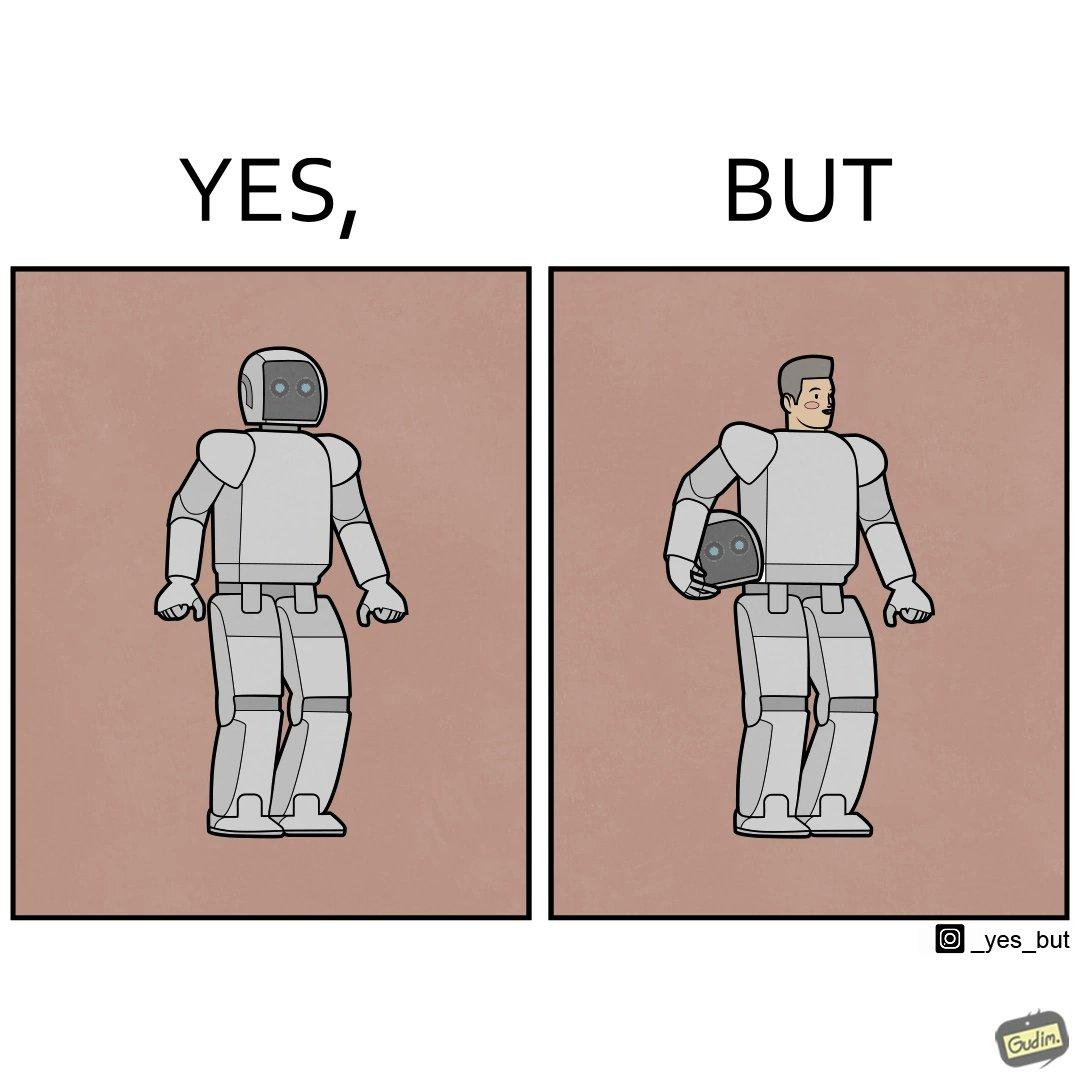What is shown in this image? The images are ironic since we work to improve technology and build innovations like robots, but in the process we ourselves become less human and robotic in the way we function. 